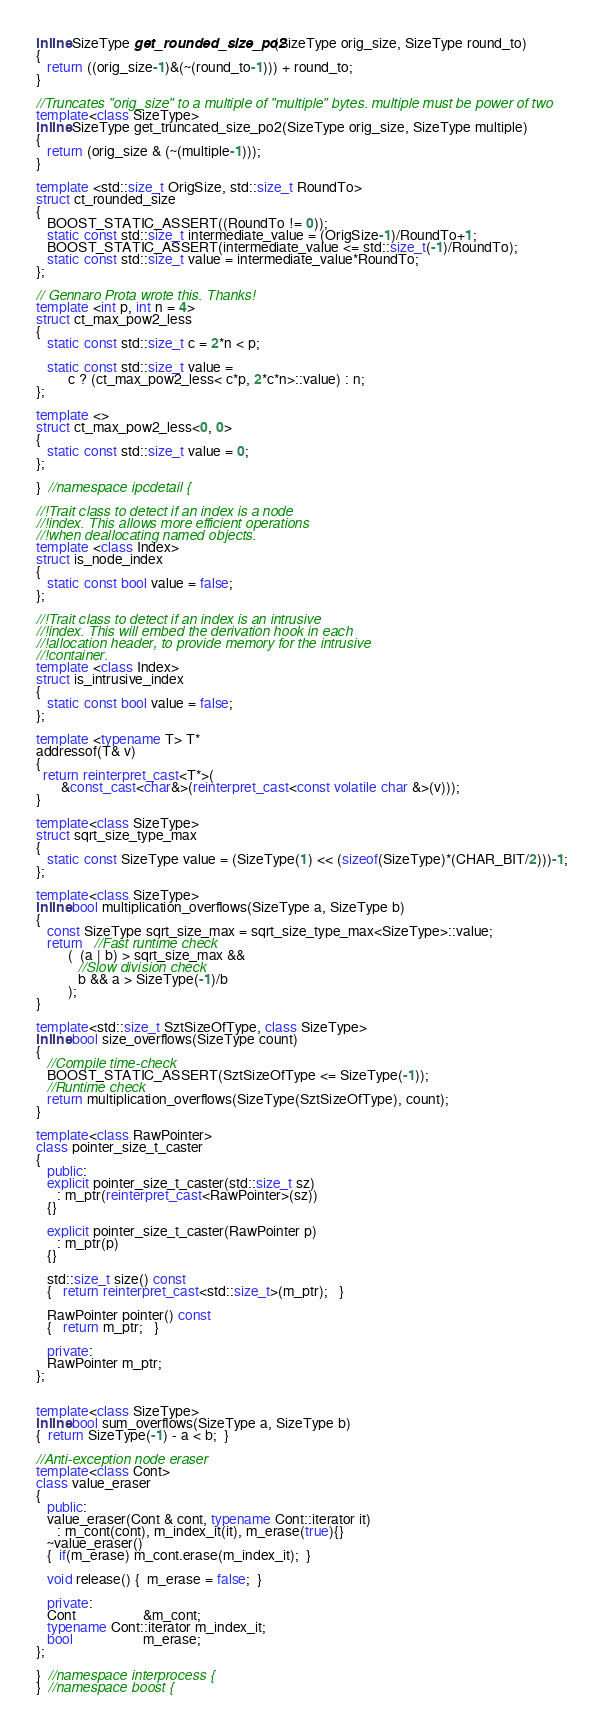Convert code to text. <code><loc_0><loc_0><loc_500><loc_500><_C++_>inline SizeType get_rounded_size_po2(SizeType orig_size, SizeType round_to)
{
   return ((orig_size-1)&(~(round_to-1))) + round_to;
}

//Truncates "orig_size" to a multiple of "multiple" bytes. multiple must be power of two
template<class SizeType>
inline SizeType get_truncated_size_po2(SizeType orig_size, SizeType multiple)
{
   return (orig_size & (~(multiple-1)));
}

template <std::size_t OrigSize, std::size_t RoundTo>
struct ct_rounded_size
{
   BOOST_STATIC_ASSERT((RoundTo != 0));
   static const std::size_t intermediate_value = (OrigSize-1)/RoundTo+1;
   BOOST_STATIC_ASSERT(intermediate_value <= std::size_t(-1)/RoundTo);
   static const std::size_t value = intermediate_value*RoundTo;
};

// Gennaro Prota wrote this. Thanks!
template <int p, int n = 4>
struct ct_max_pow2_less
{
   static const std::size_t c = 2*n < p;

   static const std::size_t value =
         c ? (ct_max_pow2_less< c*p, 2*c*n>::value) : n;
};

template <>
struct ct_max_pow2_less<0, 0>
{
   static const std::size_t value = 0;
};

}  //namespace ipcdetail {

//!Trait class to detect if an index is a node
//!index. This allows more efficient operations
//!when deallocating named objects.
template <class Index>
struct is_node_index
{
   static const bool value = false;
};

//!Trait class to detect if an index is an intrusive
//!index. This will embed the derivation hook in each
//!allocation header, to provide memory for the intrusive
//!container.
template <class Index>
struct is_intrusive_index
{
   static const bool value = false;
};

template <typename T> T*
addressof(T& v)
{
  return reinterpret_cast<T*>(
       &const_cast<char&>(reinterpret_cast<const volatile char &>(v)));
}

template<class SizeType>
struct sqrt_size_type_max
{
   static const SizeType value = (SizeType(1) << (sizeof(SizeType)*(CHAR_BIT/2)))-1;
};

template<class SizeType>
inline bool multiplication_overflows(SizeType a, SizeType b)
{
   const SizeType sqrt_size_max = sqrt_size_type_max<SizeType>::value;
   return   //Fast runtime check 
         (  (a | b) > sqrt_size_max &&
            //Slow division check 
            b && a > SizeType(-1)/b
         );
}

template<std::size_t SztSizeOfType, class SizeType>
inline bool size_overflows(SizeType count)
{
   //Compile time-check
   BOOST_STATIC_ASSERT(SztSizeOfType <= SizeType(-1));
   //Runtime check
   return multiplication_overflows(SizeType(SztSizeOfType), count);
}

template<class RawPointer>
class pointer_size_t_caster
{
   public:
   explicit pointer_size_t_caster(std::size_t sz)
      : m_ptr(reinterpret_cast<RawPointer>(sz))
   {}

   explicit pointer_size_t_caster(RawPointer p)
      : m_ptr(p)
   {}

   std::size_t size() const
   {   return reinterpret_cast<std::size_t>(m_ptr);   }

   RawPointer pointer() const
   {   return m_ptr;   }

   private:
   RawPointer m_ptr;
};


template<class SizeType>
inline bool sum_overflows(SizeType a, SizeType b)
{  return SizeType(-1) - a < b;  }

//Anti-exception node eraser
template<class Cont>
class value_eraser
{
   public:
   value_eraser(Cont & cont, typename Cont::iterator it)
      : m_cont(cont), m_index_it(it), m_erase(true){}
   ~value_eraser()
   {  if(m_erase) m_cont.erase(m_index_it);  }

   void release() {  m_erase = false;  }

   private:
   Cont                   &m_cont;
   typename Cont::iterator m_index_it;
   bool                    m_erase;
};

}  //namespace interprocess {
}  //namespace boost {
</code> 